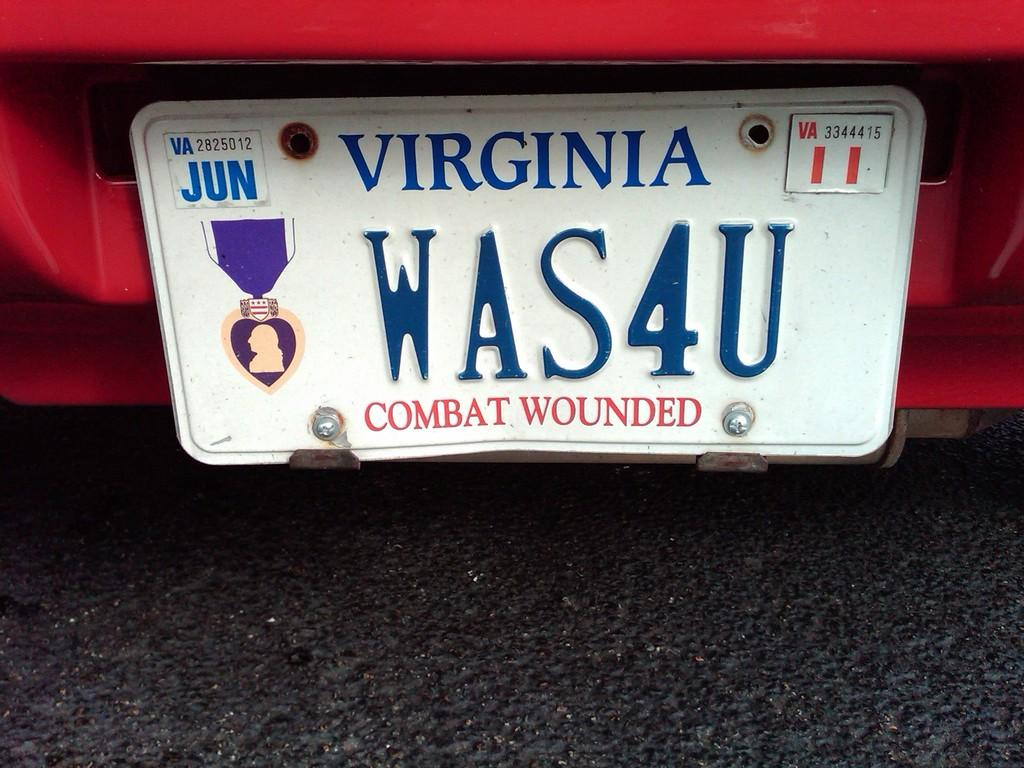What can be seen on the car in the image? There is a number plate of a car in the image. What is written on the number plate? The number plate has text on it. What is the setting of the image? There is a road visible in the image. Where is the key to unlock the car in the image? There is no key visible in the image. What type of mask is being worn by the driver in the image? There is no driver or mask present in the image. 